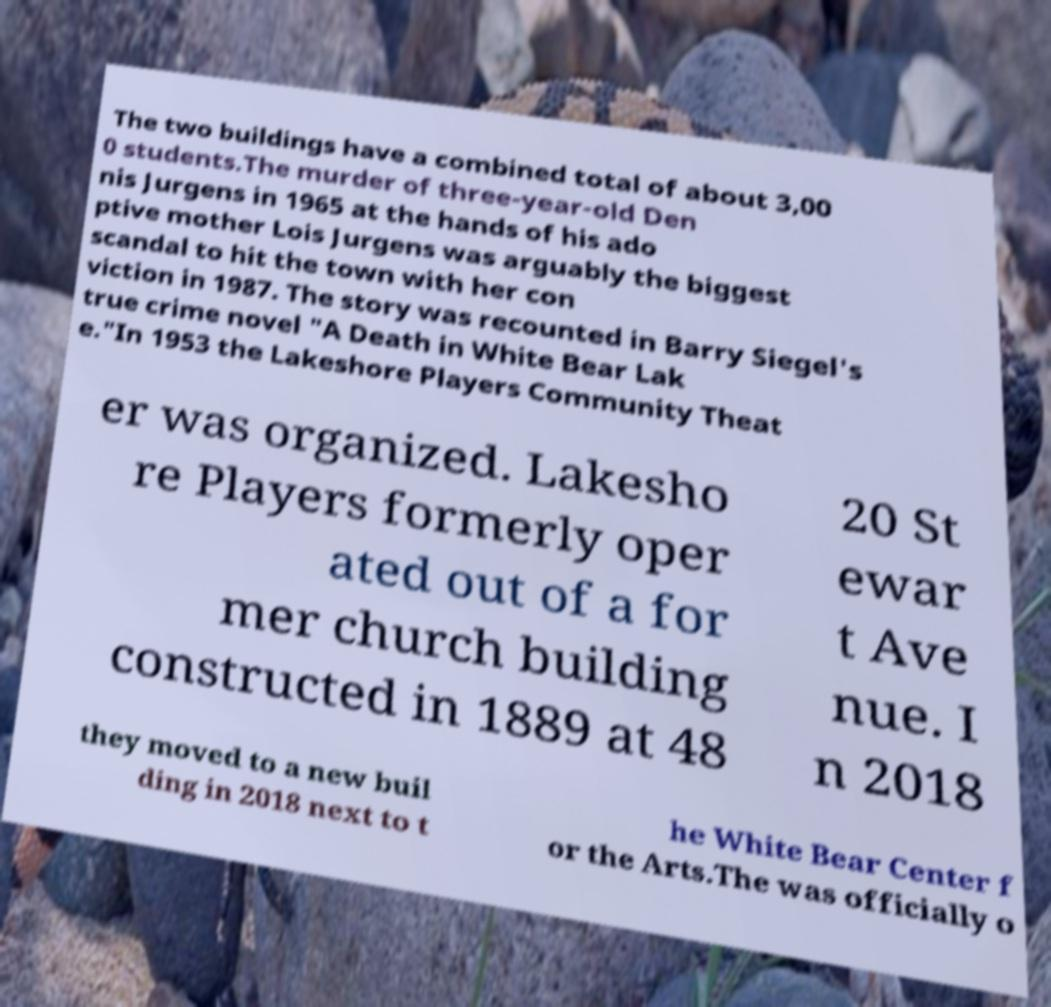Could you extract and type out the text from this image? The two buildings have a combined total of about 3,00 0 students.The murder of three-year-old Den nis Jurgens in 1965 at the hands of his ado ptive mother Lois Jurgens was arguably the biggest scandal to hit the town with her con viction in 1987. The story was recounted in Barry Siegel's true crime novel "A Death in White Bear Lak e."In 1953 the Lakeshore Players Community Theat er was organized. Lakesho re Players formerly oper ated out of a for mer church building constructed in 1889 at 48 20 St ewar t Ave nue. I n 2018 they moved to a new buil ding in 2018 next to t he White Bear Center f or the Arts.The was officially o 